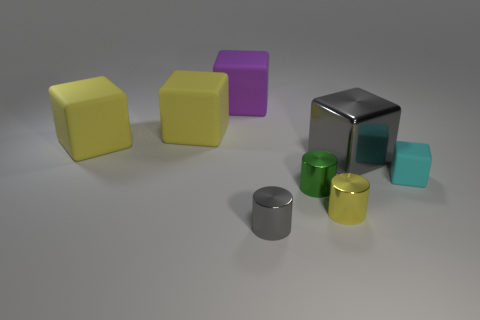There is a cyan thing to the right of the gray metallic object behind the small matte object; what shape is it?
Your answer should be very brief. Cube. Does the metal cube have the same color as the small block?
Offer a very short reply. No. What number of balls are either yellow shiny things or yellow things?
Your answer should be compact. 0. There is a cube that is both behind the small matte object and right of the purple rubber object; what is it made of?
Keep it short and to the point. Metal. There is a yellow cylinder; how many metal objects are to the left of it?
Your response must be concise. 2. Is the object that is right of the big gray object made of the same material as the tiny object left of the small green metal cylinder?
Give a very brief answer. No. What number of objects are either large rubber things in front of the big purple matte cube or big purple things?
Your response must be concise. 3. Is the number of green things right of the cyan rubber block less than the number of green metallic cylinders that are behind the purple matte object?
Your answer should be compact. No. What number of other things are there of the same size as the purple cube?
Make the answer very short. 3. Is the tiny gray cylinder made of the same material as the block to the right of the gray metallic cube?
Provide a short and direct response. No. 